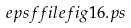Convert formula to latex. <formula><loc_0><loc_0><loc_500><loc_500>\ e p s f f i l e { f i g 1 6 . p s }</formula> 